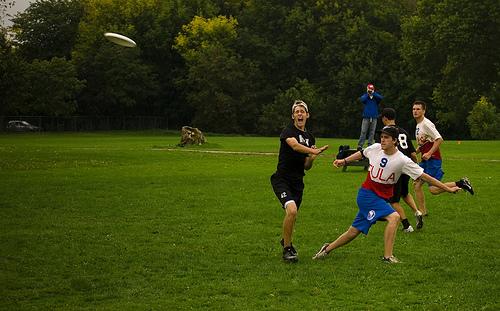Did either of the men catch the frisbee?
Give a very brief answer. Yes. What are the kids holding?
Quick response, please. Nothing. What sport are they playing?
Keep it brief. Frisbee. Are there mountains in the background?
Be succinct. No. How many people are there?
Quick response, please. 5. What color is the girl in the center's shorts?
Answer briefly. Blue. Where would you play a game of frisbee?
Keep it brief. Park. Do the players cast shadows?
Be succinct. No. How many people are wearing blue shorts?
Short answer required. 2. What is the person in the background doing?
Be succinct. Taking pictures. What color is left man's shirt?
Be succinct. Black. Does the grass look dry?
Concise answer only. No. Is the picture in focus?
Be succinct. Yes. Is this a contact sport?
Quick response, please. Yes. 